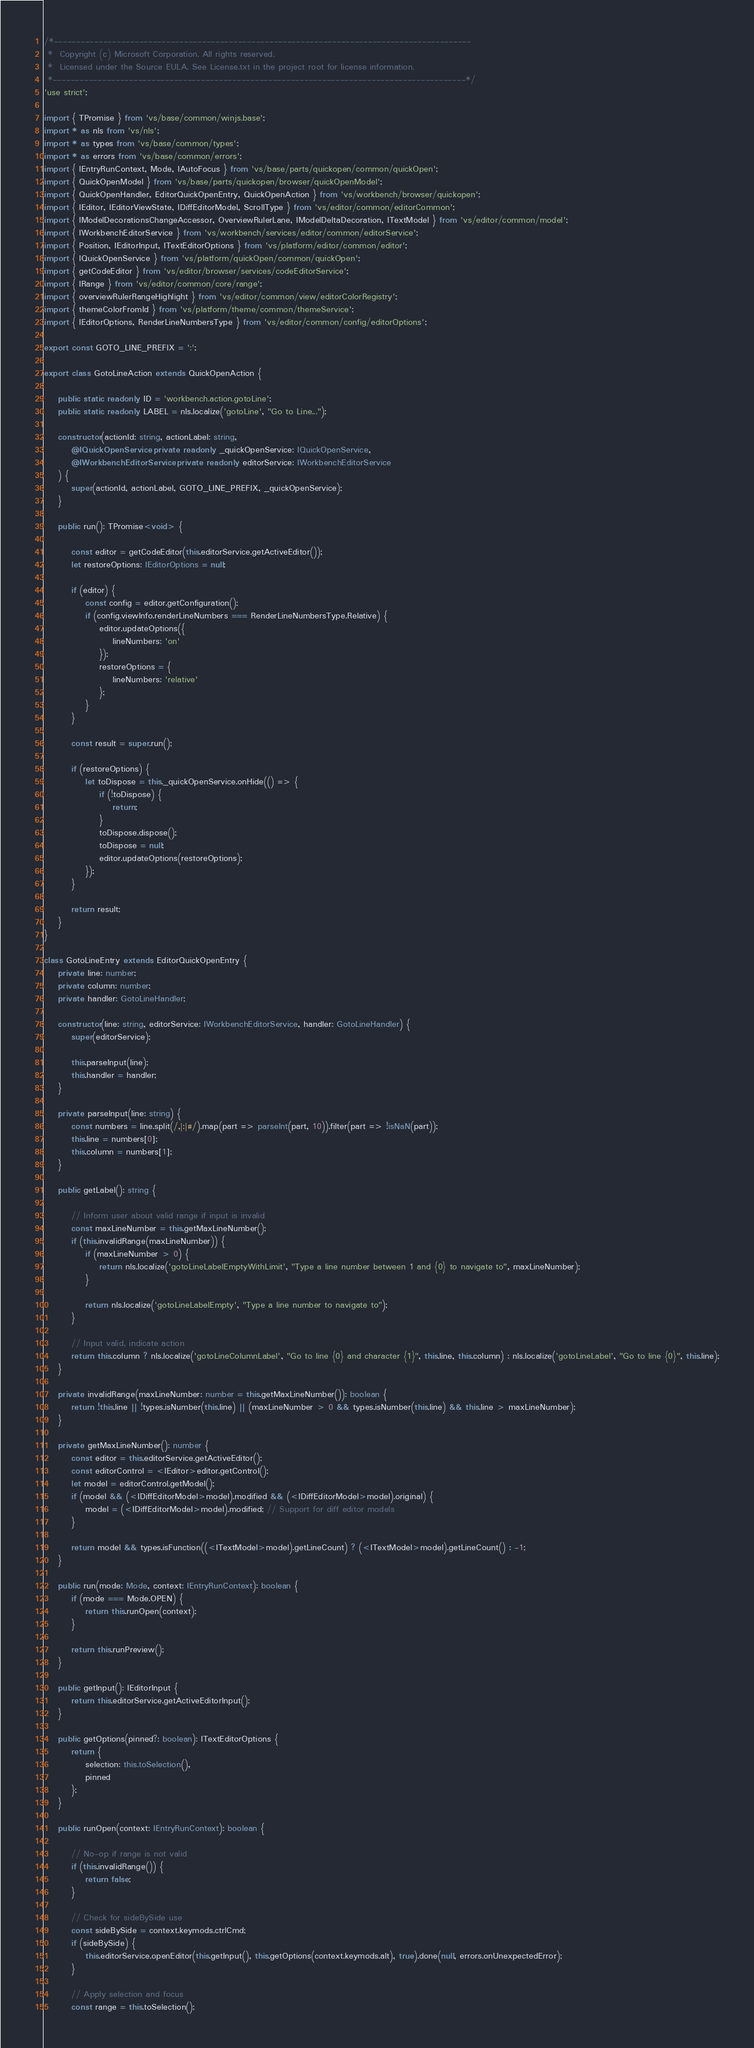<code> <loc_0><loc_0><loc_500><loc_500><_TypeScript_>/*---------------------------------------------------------------------------------------------
 *  Copyright (c) Microsoft Corporation. All rights reserved.
 *  Licensed under the Source EULA. See License.txt in the project root for license information.
 *--------------------------------------------------------------------------------------------*/
'use strict';

import { TPromise } from 'vs/base/common/winjs.base';
import * as nls from 'vs/nls';
import * as types from 'vs/base/common/types';
import * as errors from 'vs/base/common/errors';
import { IEntryRunContext, Mode, IAutoFocus } from 'vs/base/parts/quickopen/common/quickOpen';
import { QuickOpenModel } from 'vs/base/parts/quickopen/browser/quickOpenModel';
import { QuickOpenHandler, EditorQuickOpenEntry, QuickOpenAction } from 'vs/workbench/browser/quickopen';
import { IEditor, IEditorViewState, IDiffEditorModel, ScrollType } from 'vs/editor/common/editorCommon';
import { IModelDecorationsChangeAccessor, OverviewRulerLane, IModelDeltaDecoration, ITextModel } from 'vs/editor/common/model';
import { IWorkbenchEditorService } from 'vs/workbench/services/editor/common/editorService';
import { Position, IEditorInput, ITextEditorOptions } from 'vs/platform/editor/common/editor';
import { IQuickOpenService } from 'vs/platform/quickOpen/common/quickOpen';
import { getCodeEditor } from 'vs/editor/browser/services/codeEditorService';
import { IRange } from 'vs/editor/common/core/range';
import { overviewRulerRangeHighlight } from 'vs/editor/common/view/editorColorRegistry';
import { themeColorFromId } from 'vs/platform/theme/common/themeService';
import { IEditorOptions, RenderLineNumbersType } from 'vs/editor/common/config/editorOptions';

export const GOTO_LINE_PREFIX = ':';

export class GotoLineAction extends QuickOpenAction {

	public static readonly ID = 'workbench.action.gotoLine';
	public static readonly LABEL = nls.localize('gotoLine', "Go to Line...");

	constructor(actionId: string, actionLabel: string,
		@IQuickOpenService private readonly _quickOpenService: IQuickOpenService,
		@IWorkbenchEditorService private readonly editorService: IWorkbenchEditorService
	) {
		super(actionId, actionLabel, GOTO_LINE_PREFIX, _quickOpenService);
	}

	public run(): TPromise<void> {

		const editor = getCodeEditor(this.editorService.getActiveEditor());
		let restoreOptions: IEditorOptions = null;

		if (editor) {
			const config = editor.getConfiguration();
			if (config.viewInfo.renderLineNumbers === RenderLineNumbersType.Relative) {
				editor.updateOptions({
					lineNumbers: 'on'
				});
				restoreOptions = {
					lineNumbers: 'relative'
				};
			}
		}

		const result = super.run();

		if (restoreOptions) {
			let toDispose = this._quickOpenService.onHide(() => {
				if (!toDispose) {
					return;
				}
				toDispose.dispose();
				toDispose = null;
				editor.updateOptions(restoreOptions);
			});
		}

		return result;
	}
}

class GotoLineEntry extends EditorQuickOpenEntry {
	private line: number;
	private column: number;
	private handler: GotoLineHandler;

	constructor(line: string, editorService: IWorkbenchEditorService, handler: GotoLineHandler) {
		super(editorService);

		this.parseInput(line);
		this.handler = handler;
	}

	private parseInput(line: string) {
		const numbers = line.split(/,|:|#/).map(part => parseInt(part, 10)).filter(part => !isNaN(part));
		this.line = numbers[0];
		this.column = numbers[1];
	}

	public getLabel(): string {

		// Inform user about valid range if input is invalid
		const maxLineNumber = this.getMaxLineNumber();
		if (this.invalidRange(maxLineNumber)) {
			if (maxLineNumber > 0) {
				return nls.localize('gotoLineLabelEmptyWithLimit', "Type a line number between 1 and {0} to navigate to", maxLineNumber);
			}

			return nls.localize('gotoLineLabelEmpty', "Type a line number to navigate to");
		}

		// Input valid, indicate action
		return this.column ? nls.localize('gotoLineColumnLabel', "Go to line {0} and character {1}", this.line, this.column) : nls.localize('gotoLineLabel', "Go to line {0}", this.line);
	}

	private invalidRange(maxLineNumber: number = this.getMaxLineNumber()): boolean {
		return !this.line || !types.isNumber(this.line) || (maxLineNumber > 0 && types.isNumber(this.line) && this.line > maxLineNumber);
	}

	private getMaxLineNumber(): number {
		const editor = this.editorService.getActiveEditor();
		const editorControl = <IEditor>editor.getControl();
		let model = editorControl.getModel();
		if (model && (<IDiffEditorModel>model).modified && (<IDiffEditorModel>model).original) {
			model = (<IDiffEditorModel>model).modified; // Support for diff editor models
		}

		return model && types.isFunction((<ITextModel>model).getLineCount) ? (<ITextModel>model).getLineCount() : -1;
	}

	public run(mode: Mode, context: IEntryRunContext): boolean {
		if (mode === Mode.OPEN) {
			return this.runOpen(context);
		}

		return this.runPreview();
	}

	public getInput(): IEditorInput {
		return this.editorService.getActiveEditorInput();
	}

	public getOptions(pinned?: boolean): ITextEditorOptions {
		return {
			selection: this.toSelection(),
			pinned
		};
	}

	public runOpen(context: IEntryRunContext): boolean {

		// No-op if range is not valid
		if (this.invalidRange()) {
			return false;
		}

		// Check for sideBySide use
		const sideBySide = context.keymods.ctrlCmd;
		if (sideBySide) {
			this.editorService.openEditor(this.getInput(), this.getOptions(context.keymods.alt), true).done(null, errors.onUnexpectedError);
		}

		// Apply selection and focus
		const range = this.toSelection();</code> 